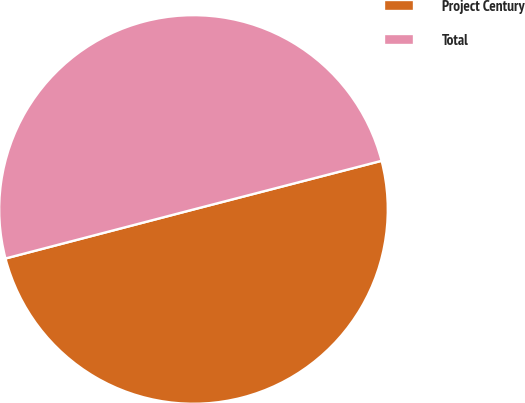Convert chart to OTSL. <chart><loc_0><loc_0><loc_500><loc_500><pie_chart><fcel>Project Century<fcel>Total<nl><fcel>49.97%<fcel>50.03%<nl></chart> 